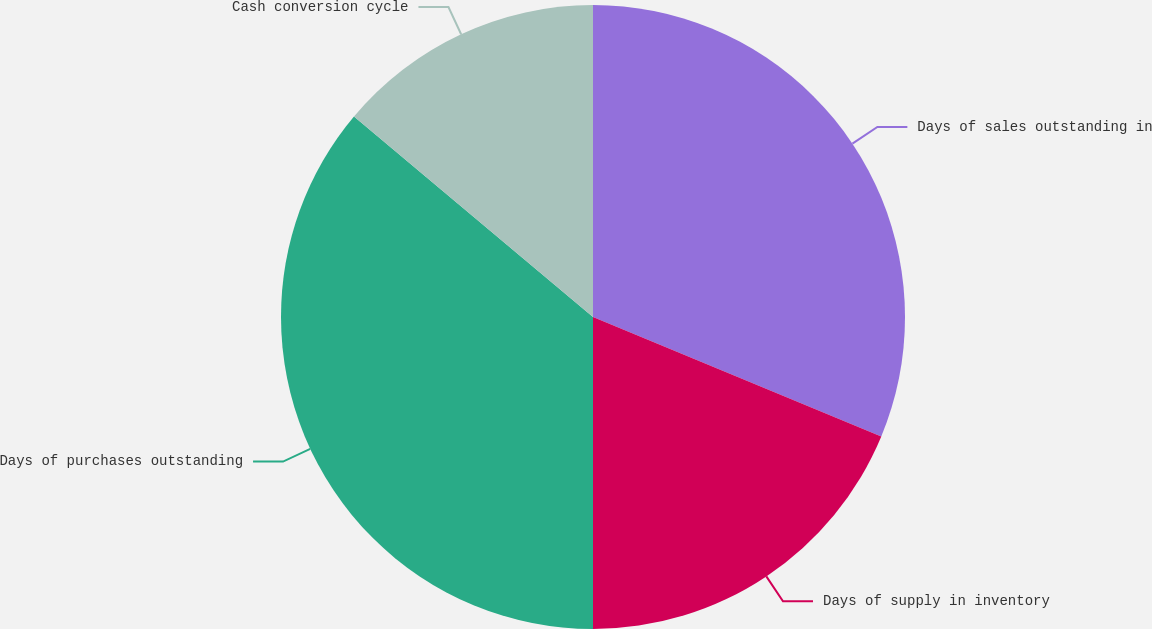Convert chart to OTSL. <chart><loc_0><loc_0><loc_500><loc_500><pie_chart><fcel>Days of sales outstanding in<fcel>Days of supply in inventory<fcel>Days of purchases outstanding<fcel>Cash conversion cycle<nl><fcel>31.25%<fcel>18.75%<fcel>36.11%<fcel>13.89%<nl></chart> 